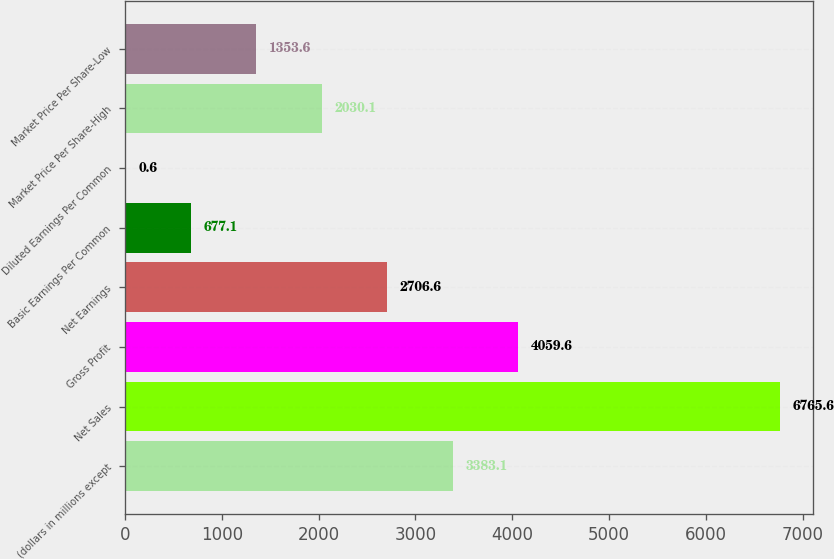Convert chart to OTSL. <chart><loc_0><loc_0><loc_500><loc_500><bar_chart><fcel>(dollars in millions except<fcel>Net Sales<fcel>Gross Profit<fcel>Net Earnings<fcel>Basic Earnings Per Common<fcel>Diluted Earnings Per Common<fcel>Market Price Per Share-High<fcel>Market Price Per Share-Low<nl><fcel>3383.1<fcel>6765.6<fcel>4059.6<fcel>2706.6<fcel>677.1<fcel>0.6<fcel>2030.1<fcel>1353.6<nl></chart> 